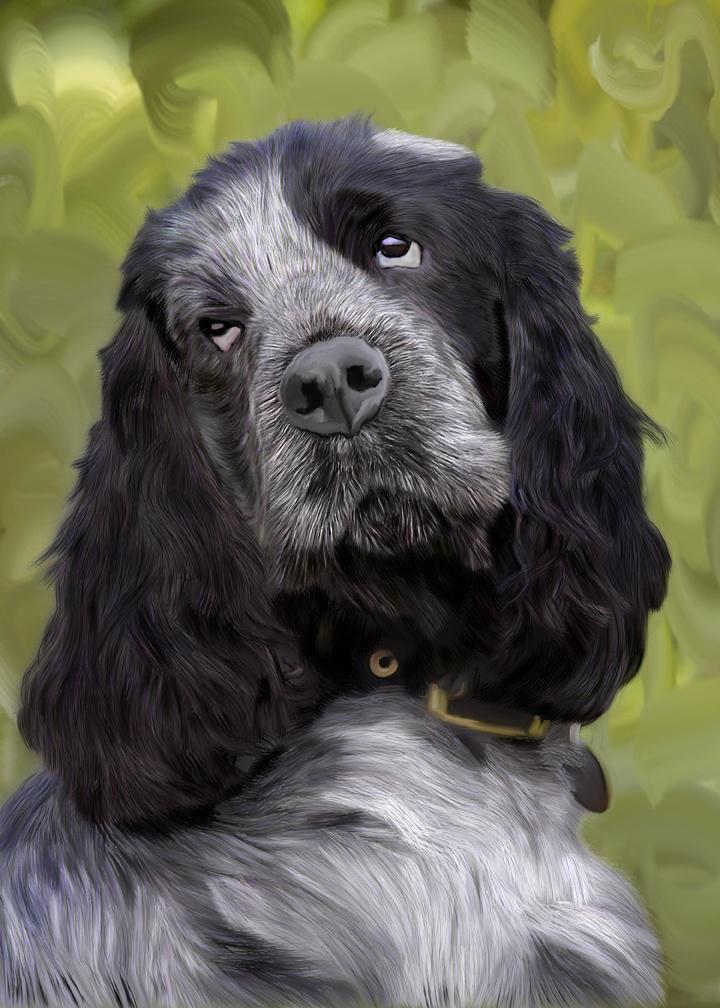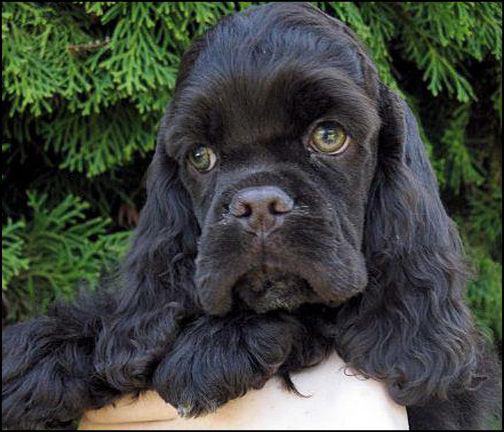The first image is the image on the left, the second image is the image on the right. Given the left and right images, does the statement "The dog in the image on the right is being held up outside." hold true? Answer yes or no. Yes. 